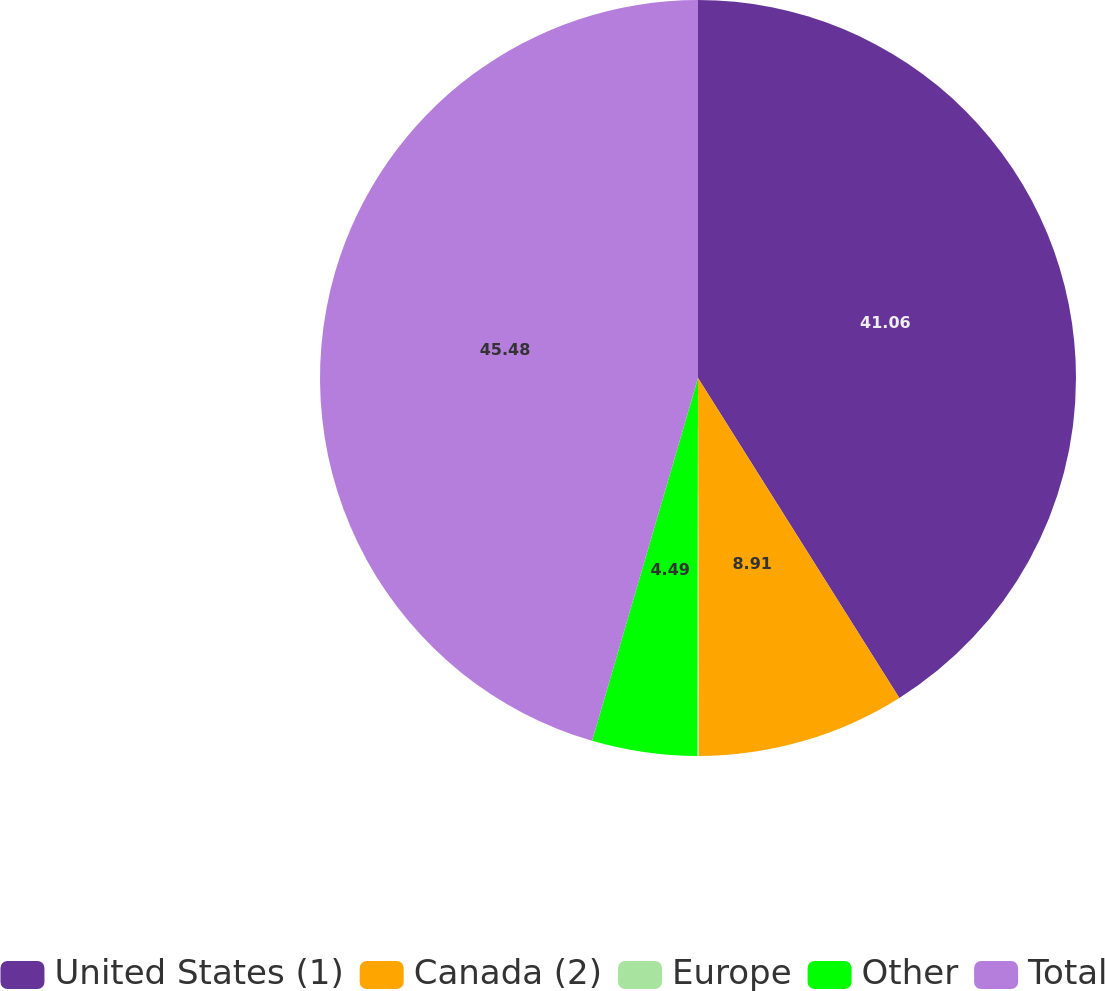Convert chart to OTSL. <chart><loc_0><loc_0><loc_500><loc_500><pie_chart><fcel>United States (1)<fcel>Canada (2)<fcel>Europe<fcel>Other<fcel>Total<nl><fcel>41.06%<fcel>8.91%<fcel>0.06%<fcel>4.49%<fcel>45.48%<nl></chart> 